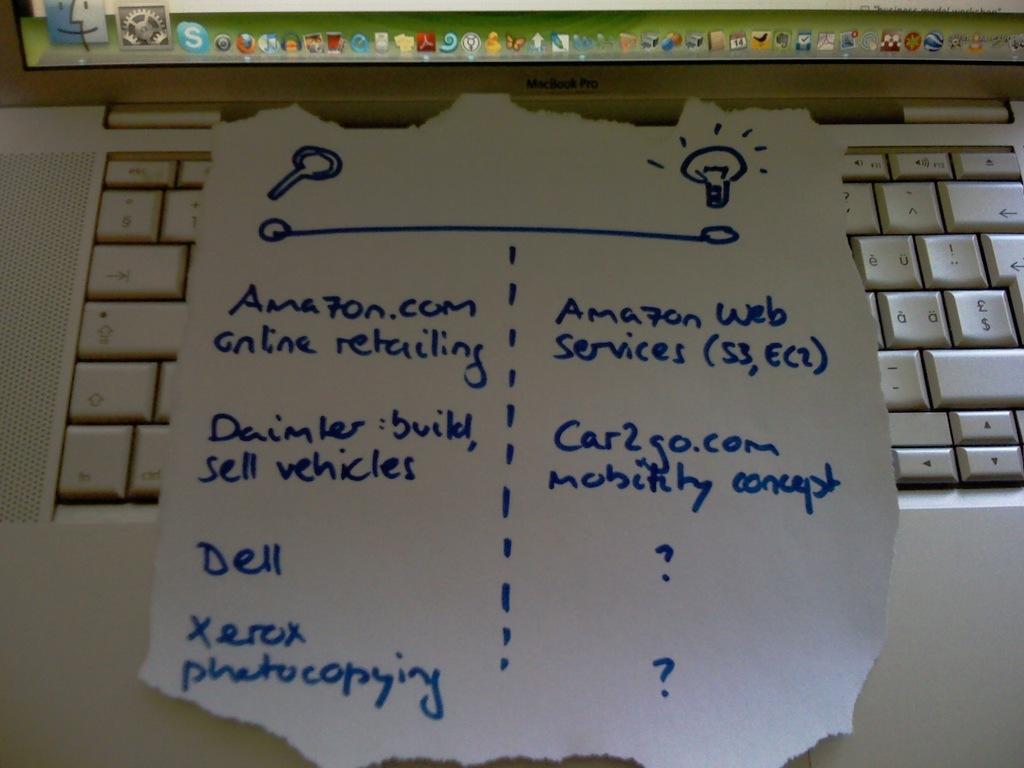What is the companies listed on the paper?
Your response must be concise. Amazon dell xerox car2go. 